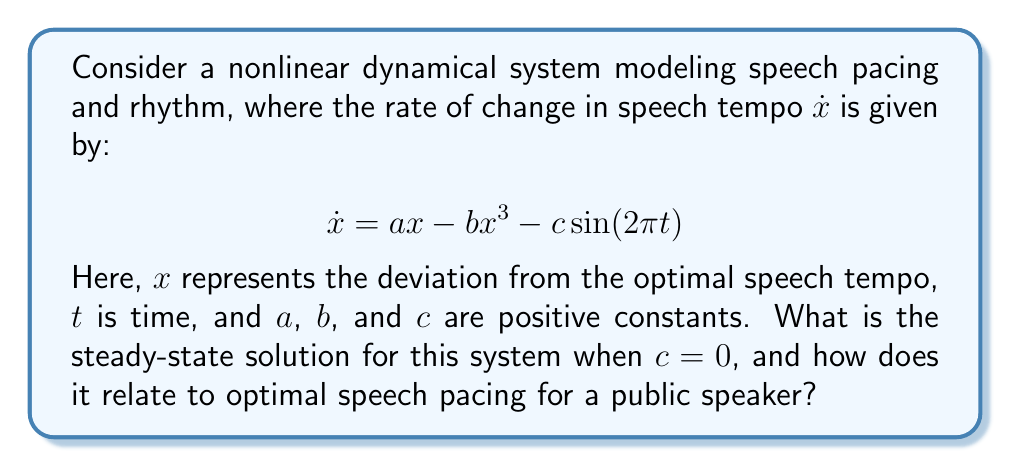Show me your answer to this math problem. To find the steady-state solution when $c = 0$, we follow these steps:

1) With $c = 0$, the system simplifies to:
   $$\dot{x} = ax - bx^3$$

2) At steady-state, $\dot{x} = 0$, so:
   $$0 = ax - bx^3$$

3) Factor out $x$:
   $$x(a - bx^2) = 0$$

4) Solve for $x$:
   $x = 0$ or $x = \pm \sqrt{\frac{a}{b}}$

5) Interpret the solutions:
   - $x = 0$ represents the optimal speech tempo (no deviation).
   - $x = \pm \sqrt{\frac{a}{b}}$ represents two stable deviations from the optimal tempo.

6) For a public speaker, this means:
   - The speaker naturally tends towards either the optimal pace ($x = 0$) or
   - Two stable, slightly off-optimal paces ($x = \pm \sqrt{\frac{a}{b}}$)

7) The ratio $\frac{a}{b}$ determines the magnitude of these stable deviations. A smaller ratio means the stable deviations are closer to the optimal pace.
Answer: $x = 0, \pm \sqrt{\frac{a}{b}}$ 